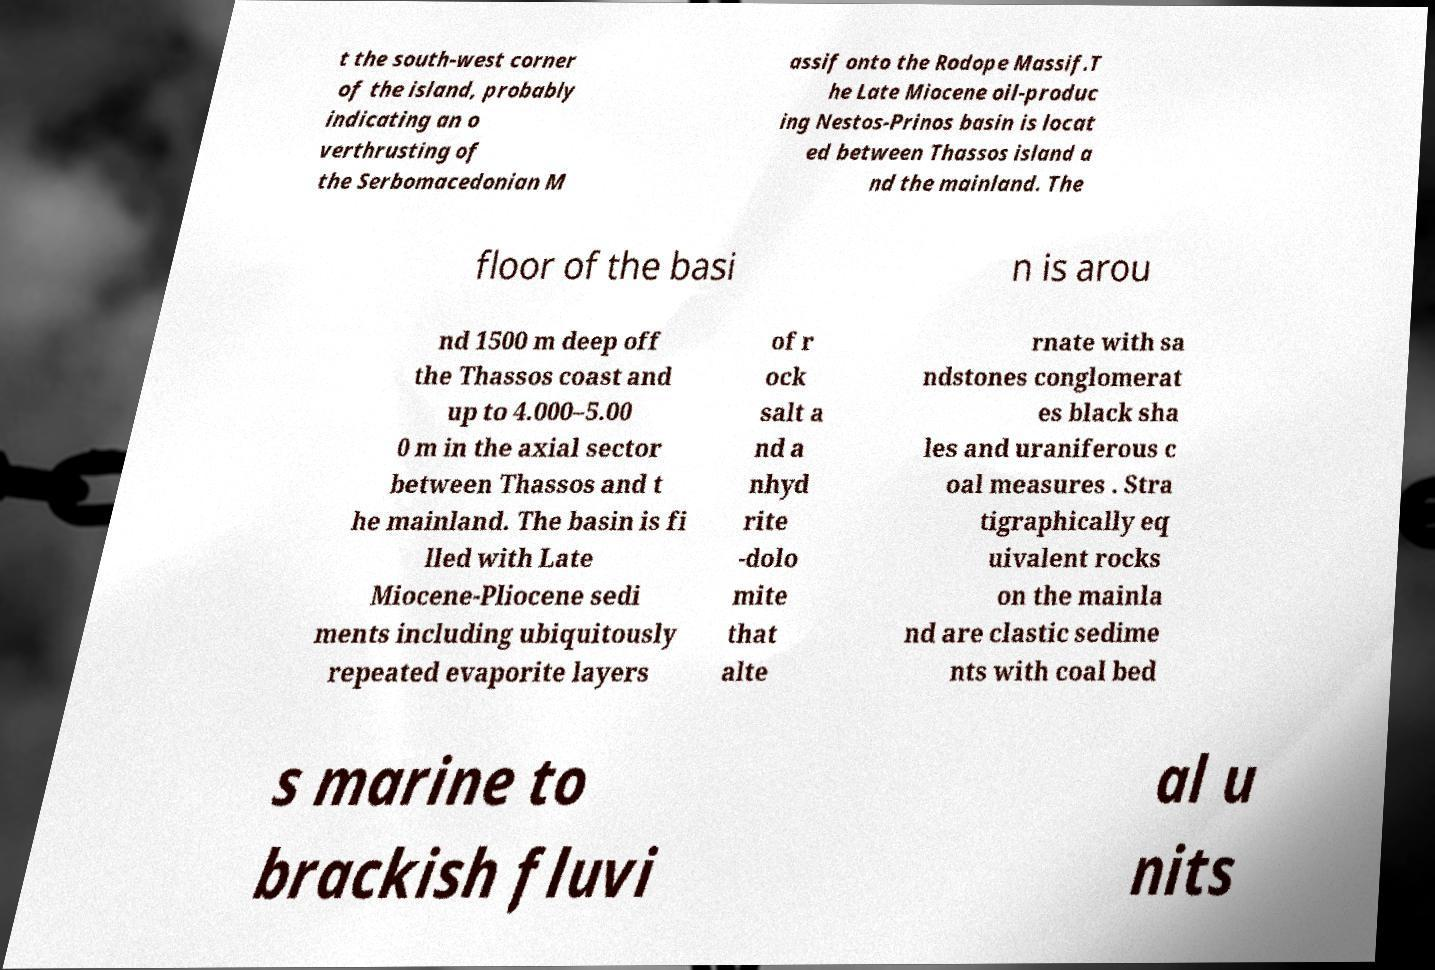What messages or text are displayed in this image? I need them in a readable, typed format. t the south-west corner of the island, probably indicating an o verthrusting of the Serbomacedonian M assif onto the Rodope Massif.T he Late Miocene oil-produc ing Nestos-Prinos basin is locat ed between Thassos island a nd the mainland. The floor of the basi n is arou nd 1500 m deep off the Thassos coast and up to 4.000–5.00 0 m in the axial sector between Thassos and t he mainland. The basin is fi lled with Late Miocene-Pliocene sedi ments including ubiquitously repeated evaporite layers of r ock salt a nd a nhyd rite -dolo mite that alte rnate with sa ndstones conglomerat es black sha les and uraniferous c oal measures . Stra tigraphically eq uivalent rocks on the mainla nd are clastic sedime nts with coal bed s marine to brackish fluvi al u nits 